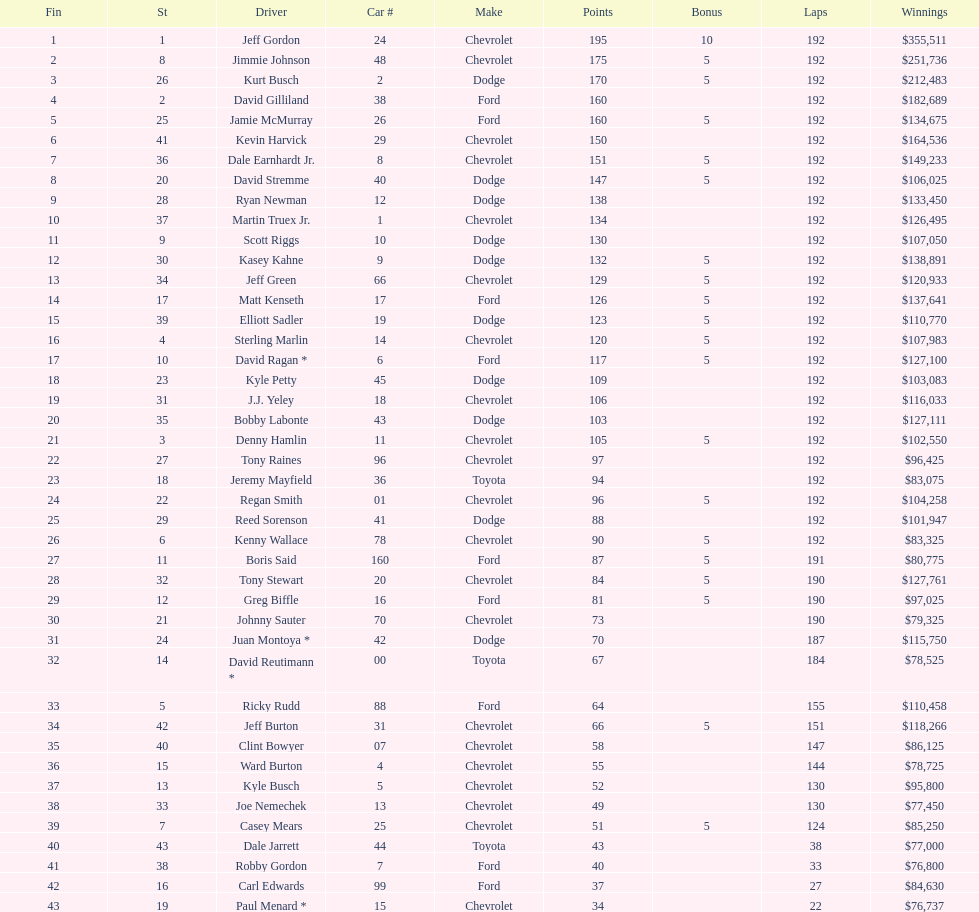How many drivers earned 5 bonus each in the race? 19. 